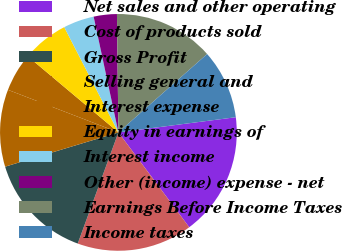Convert chart. <chart><loc_0><loc_0><loc_500><loc_500><pie_chart><fcel>Net sales and other operating<fcel>Cost of products sold<fcel>Gross Profit<fcel>Selling general and<fcel>Interest expense<fcel>Equity in earnings of<fcel>Interest income<fcel>Other (income) expense - net<fcel>Earnings Before Income Taxes<fcel>Income taxes<nl><fcel>16.84%<fcel>15.79%<fcel>14.74%<fcel>10.53%<fcel>5.26%<fcel>6.32%<fcel>4.21%<fcel>3.16%<fcel>13.68%<fcel>9.47%<nl></chart> 